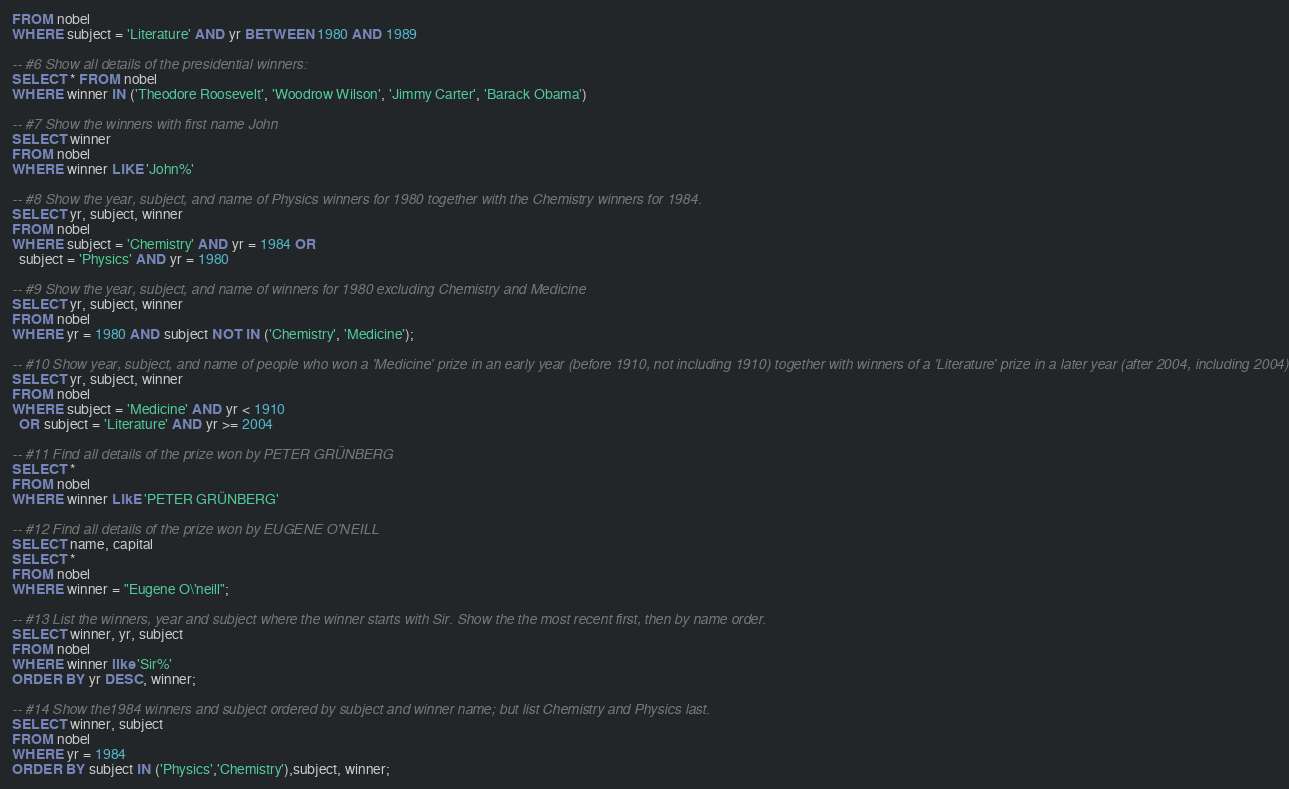<code> <loc_0><loc_0><loc_500><loc_500><_SQL_>FROM nobel
WHERE subject = 'Literature' AND yr BETWEEN 1980 AND 1989

-- #6 Show all details of the presidential winners:
SELECT * FROM nobel
WHERE winner IN ('Theodore Roosevelt', 'Woodrow Wilson', 'Jimmy Carter', 'Barack Obama')

-- #7 Show the winners with first name John
SELECT winner
FROM nobel
WHERE winner LIKE 'John%'

-- #8 Show the year, subject, and name of Physics winners for 1980 together with the Chemistry winners for 1984.
SELECT yr, subject, winner
FROM nobel
WHERE subject = 'Chemistry' AND yr = 1984 OR
  subject = 'Physics' AND yr = 1980

-- #9 Show the year, subject, and name of winners for 1980 excluding Chemistry and Medicine
SELECT yr, subject, winner
FROM nobel
WHERE yr = 1980 AND subject NOT IN ('Chemistry', 'Medicine');

-- #10 Show year, subject, and name of people who won a 'Medicine' prize in an early year (before 1910, not including 1910) together with winners of a 'Literature' prize in a later year (after 2004, including 2004)
SELECT yr, subject, winner
FROM nobel
WHERE subject = 'Medicine' AND yr < 1910
  OR subject = 'Literature' AND yr >= 2004

-- #11 Find all details of the prize won by PETER GRÜNBERG
SELECT *
FROM nobel
WHERE winner LIkE 'PETER GRÜNBERG'

-- #12 Find all details of the prize won by EUGENE O'NEILL
SELECT name, capital
SELECT *
FROM nobel
WHERE winner = "Eugene O\'neill";

-- #13 List the winners, year and subject where the winner starts with Sir. Show the the most recent first, then by name order.
SELECT winner, yr, subject
FROM nobel
WHERE winner like 'Sir%'
ORDER BY yr DESC, winner;

-- #14 Show the1984 winners and subject ordered by subject and winner name; but list Chemistry and Physics last.
SELECT winner, subject
FROM nobel
WHERE yr = 1984
ORDER BY subject IN ('Physics','Chemistry'),subject, winner;</code> 